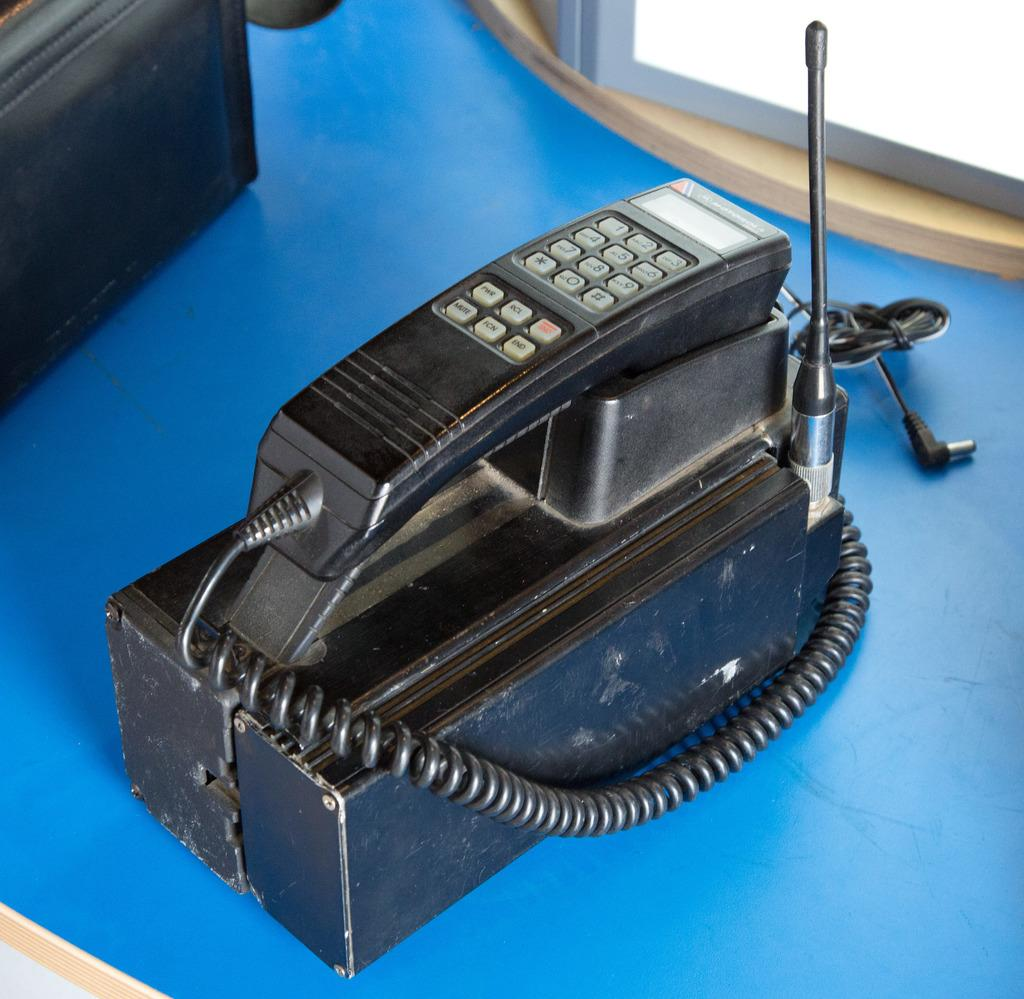What object can be seen in the image? There is a telephone in the image. Where is the telephone located? The telephone is placed on a table. What type of seafood is being sold in the image? There is no seafood or produce present in the image; it only features a telephone on a table. 